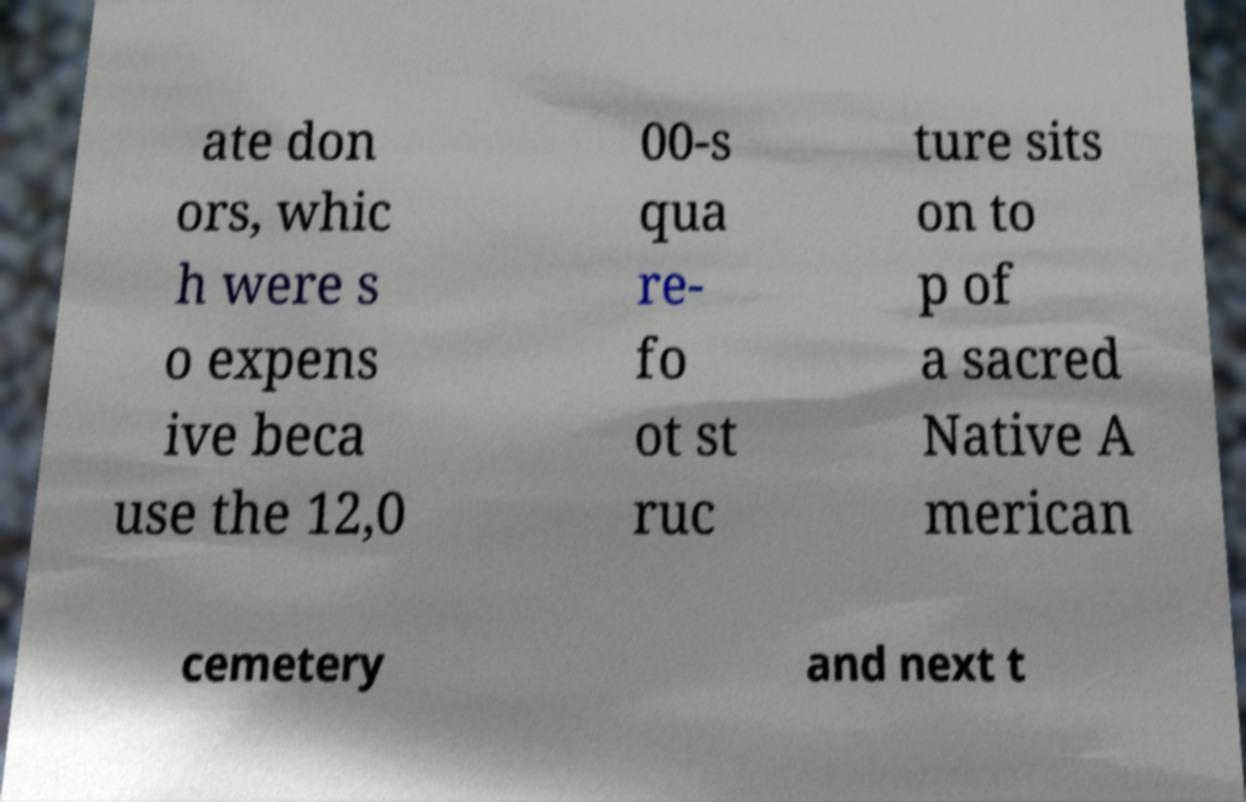Please read and relay the text visible in this image. What does it say? ate don ors, whic h were s o expens ive beca use the 12,0 00-s qua re- fo ot st ruc ture sits on to p of a sacred Native A merican cemetery and next t 